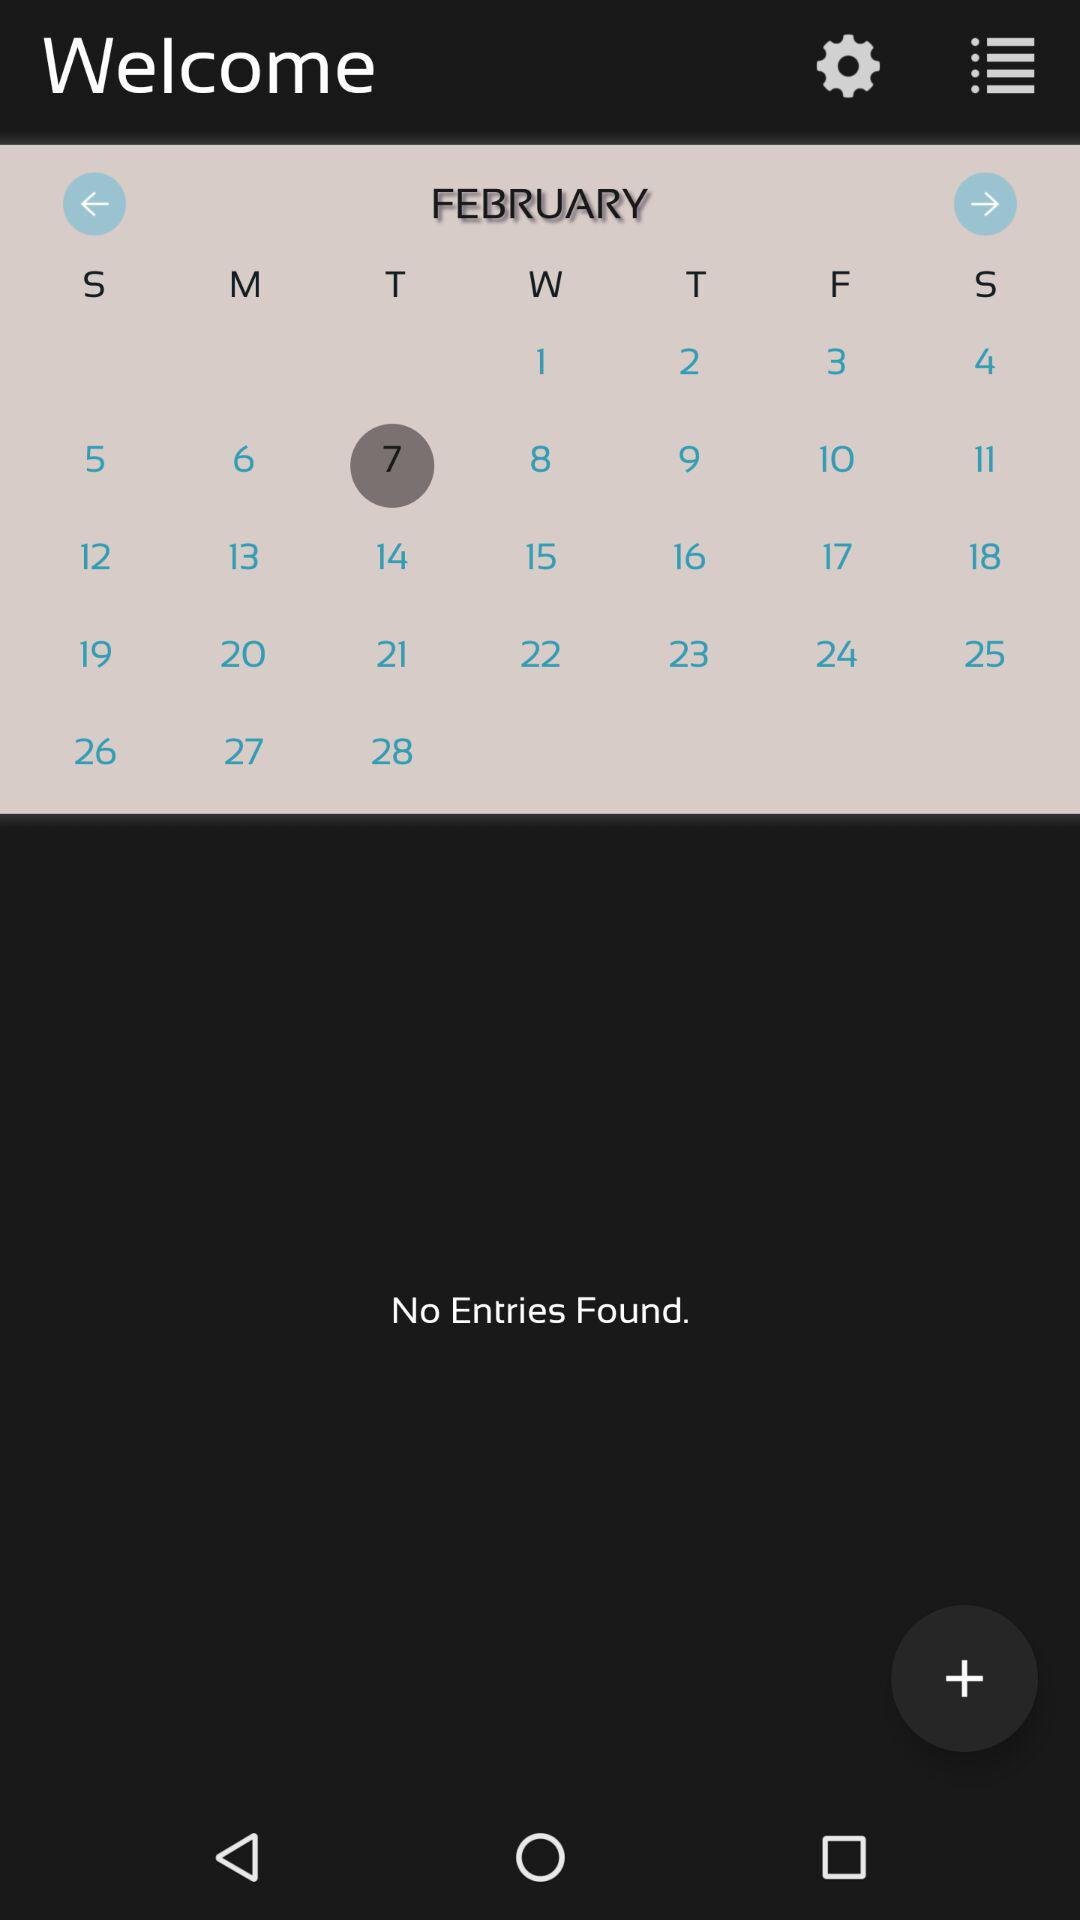What date is selected? The selected date is Tuesday, February 7th. 